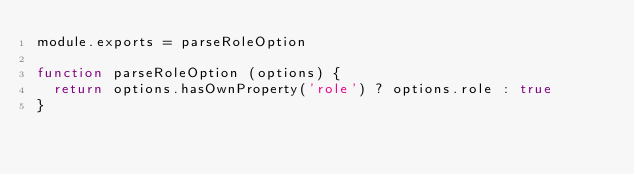<code> <loc_0><loc_0><loc_500><loc_500><_JavaScript_>module.exports = parseRoleOption

function parseRoleOption (options) {
  return options.hasOwnProperty('role') ? options.role : true
}
</code> 